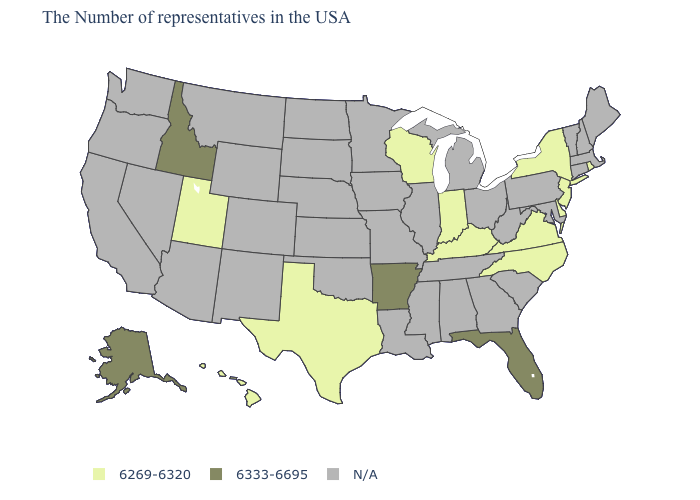What is the lowest value in states that border Michigan?
Be succinct. 6269-6320. Which states have the lowest value in the South?
Concise answer only. Delaware, Virginia, North Carolina, Kentucky, Texas. Name the states that have a value in the range N/A?
Concise answer only. Maine, Massachusetts, New Hampshire, Vermont, Connecticut, Maryland, Pennsylvania, South Carolina, West Virginia, Ohio, Georgia, Michigan, Alabama, Tennessee, Illinois, Mississippi, Louisiana, Missouri, Minnesota, Iowa, Kansas, Nebraska, Oklahoma, South Dakota, North Dakota, Wyoming, Colorado, New Mexico, Montana, Arizona, Nevada, California, Washington, Oregon. What is the value of South Dakota?
Concise answer only. N/A. What is the value of Mississippi?
Short answer required. N/A. What is the value of Alabama?
Give a very brief answer. N/A. What is the value of New Mexico?
Keep it brief. N/A. What is the value of Washington?
Give a very brief answer. N/A. Name the states that have a value in the range N/A?
Keep it brief. Maine, Massachusetts, New Hampshire, Vermont, Connecticut, Maryland, Pennsylvania, South Carolina, West Virginia, Ohio, Georgia, Michigan, Alabama, Tennessee, Illinois, Mississippi, Louisiana, Missouri, Minnesota, Iowa, Kansas, Nebraska, Oklahoma, South Dakota, North Dakota, Wyoming, Colorado, New Mexico, Montana, Arizona, Nevada, California, Washington, Oregon. Does New Jersey have the highest value in the USA?
Quick response, please. No. Name the states that have a value in the range 6269-6320?
Write a very short answer. Rhode Island, New York, New Jersey, Delaware, Virginia, North Carolina, Kentucky, Indiana, Wisconsin, Texas, Utah, Hawaii. Is the legend a continuous bar?
Answer briefly. No. Among the states that border Montana , which have the highest value?
Keep it brief. Idaho. Name the states that have a value in the range 6269-6320?
Concise answer only. Rhode Island, New York, New Jersey, Delaware, Virginia, North Carolina, Kentucky, Indiana, Wisconsin, Texas, Utah, Hawaii. Does the first symbol in the legend represent the smallest category?
Concise answer only. Yes. 